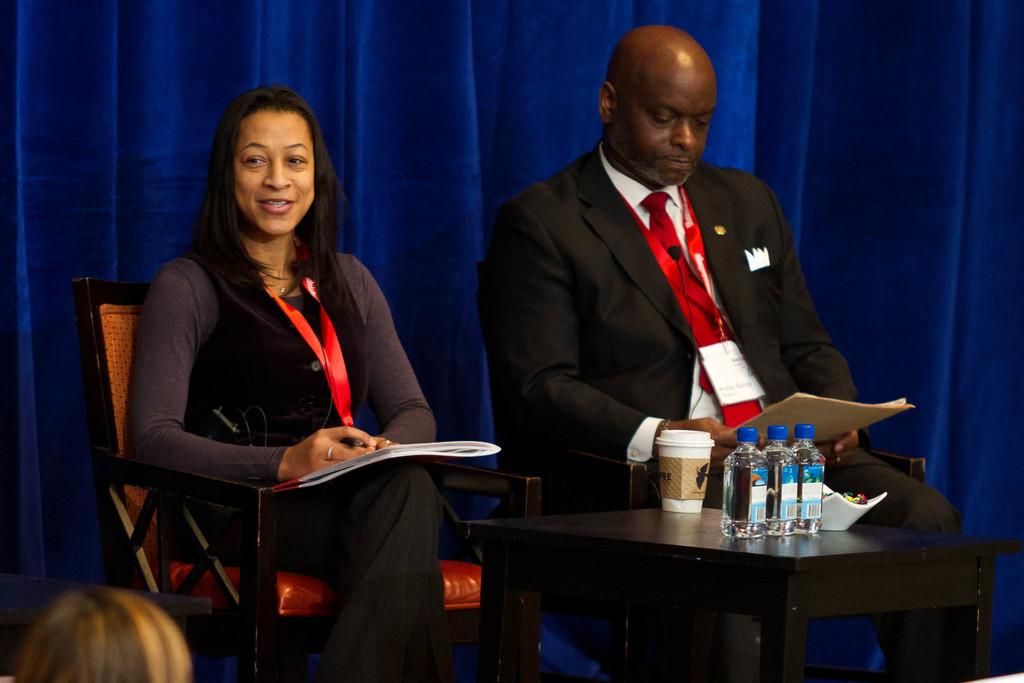What are the people in the image doing? The people in the image are sitting on chairs. What can be seen on the table in the image? There are water bottles and a coffee cup on the table. What type of steel is used to construct the chairs in the image? There is no information about the chairs' construction material in the image, so it cannot be determined if steel is used. 